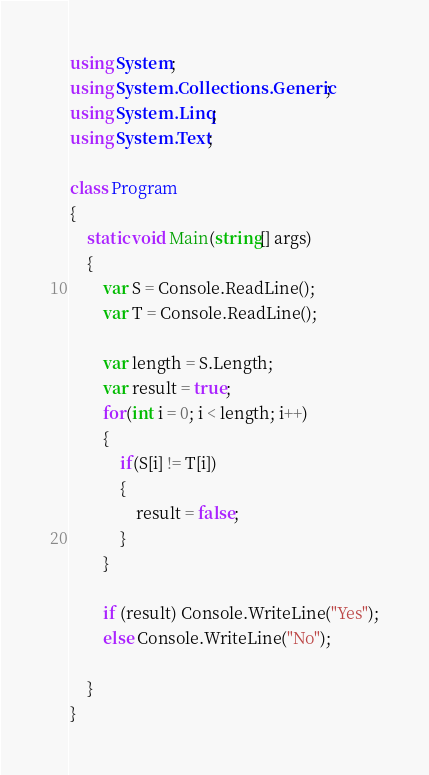<code> <loc_0><loc_0><loc_500><loc_500><_C#_>using System;
using System.Collections.Generic;
using System.Linq;
using System.Text;

class Program
{
    static void Main(string[] args)
    {
        var S = Console.ReadLine();
        var T = Console.ReadLine();

        var length = S.Length;
        var result = true;
        for(int i = 0; i < length; i++)
        {
            if(S[i] != T[i])
            {
                result = false;
            }
        }

        if (result) Console.WriteLine("Yes");
        else Console.WriteLine("No");

    }
}
</code> 